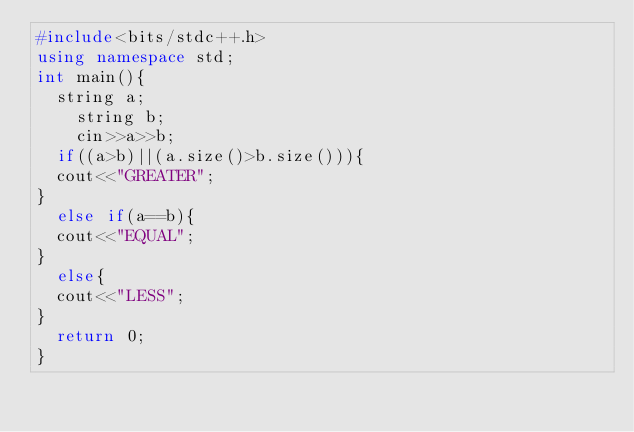<code> <loc_0><loc_0><loc_500><loc_500><_C++_>#include<bits/stdc++.h>
using namespace std;
int main(){
	string a;
    string b;
    cin>>a>>b;
	if((a>b)||(a.size()>b.size())){
	cout<<"GREATER";
}
	else if(a==b){
	cout<<"EQUAL";
}
	else{
	cout<<"LESS";
}
	return 0;
}</code> 